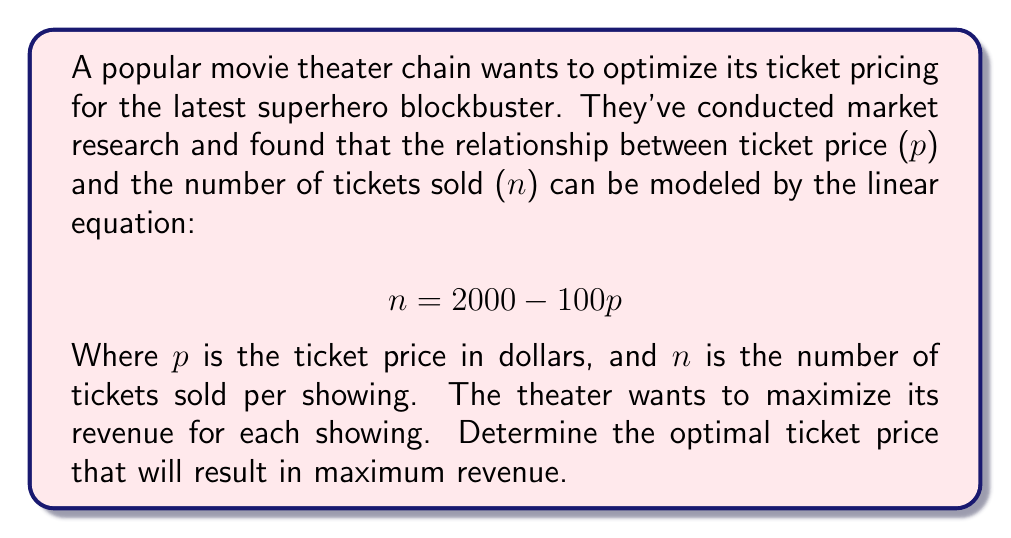Show me your answer to this math problem. To solve this problem, we need to follow these steps:

1) First, let's define the revenue function. Revenue is the product of price per ticket and the number of tickets sold:

   $$ R = pn $$

2) We can substitute the given equation for $n$ into our revenue function:

   $$ R = p(2000 - 100p) = 2000p - 100p^2 $$

3) To find the maximum revenue, we need to find the vertex of this quadratic function. We can do this by finding where the derivative of R with respect to p equals zero:

   $$ \frac{dR}{dp} = 2000 - 200p $$

4) Set this equal to zero and solve for p:

   $$ 2000 - 200p = 0 $$
   $$ -200p = -2000 $$
   $$ p = 10 $$

5) To confirm this is a maximum (not a minimum), we can check that the second derivative is negative:

   $$ \frac{d^2R}{dp^2} = -200 $$

   Since this is negative, we confirm that $p = 10$ gives us the maximum revenue.

6) We can calculate the number of tickets sold at this price:

   $$ n = 2000 - 100(10) = 1000 $$

7) And the maximum revenue:

   $$ R = 10 * 1000 = 10,000 $$
Answer: The optimal ticket price to maximize revenue is $10. At this price, the theater will sell 1000 tickets and generate $10,000 in revenue per showing. 